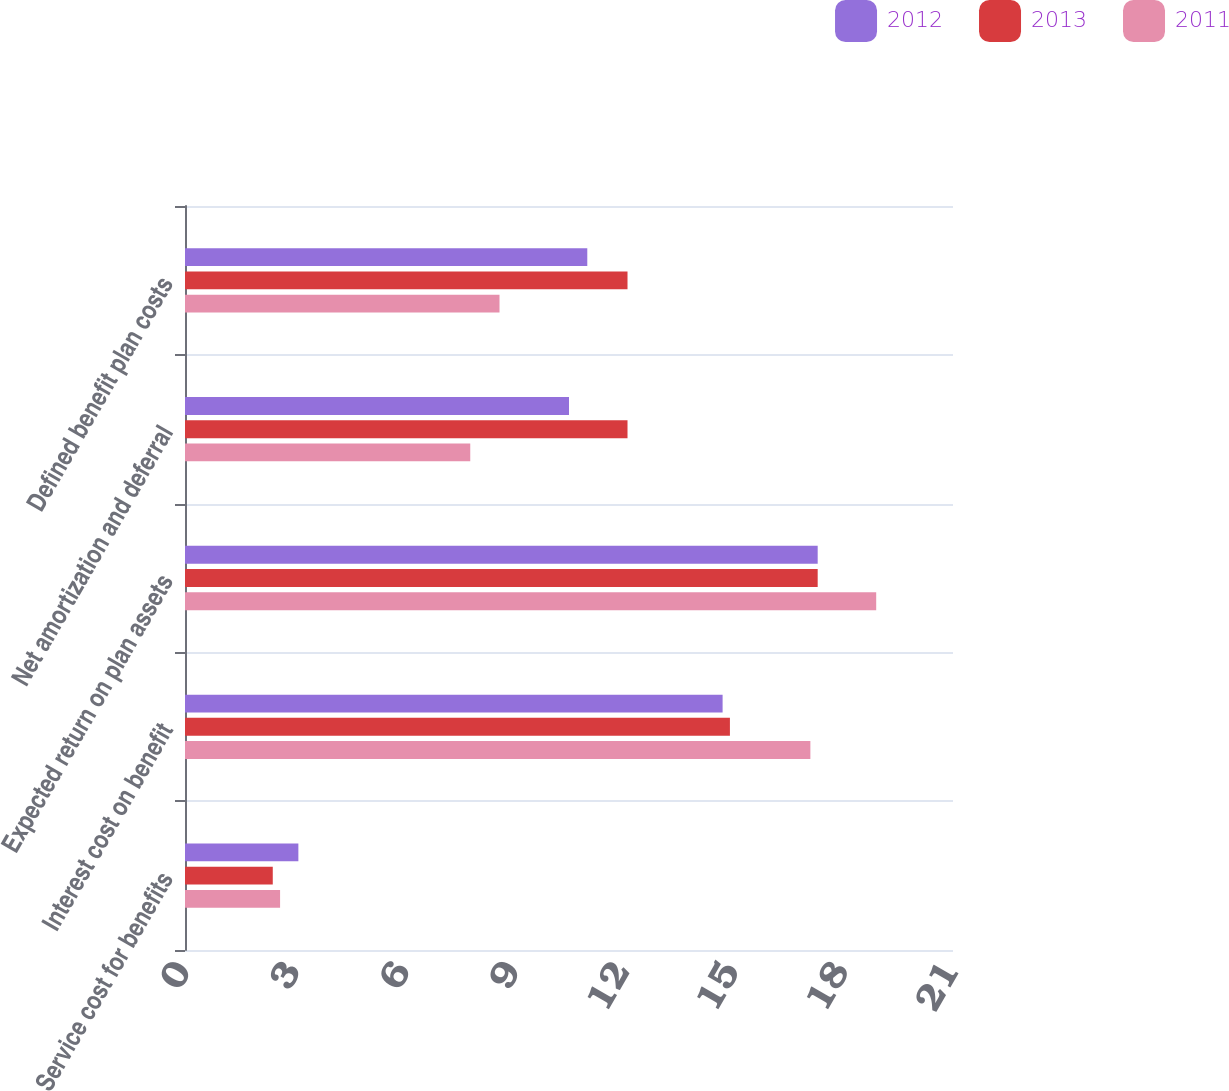Convert chart to OTSL. <chart><loc_0><loc_0><loc_500><loc_500><stacked_bar_chart><ecel><fcel>Service cost for benefits<fcel>Interest cost on benefit<fcel>Expected return on plan assets<fcel>Net amortization and deferral<fcel>Defined benefit plan costs<nl><fcel>2012<fcel>3.1<fcel>14.7<fcel>17.3<fcel>10.5<fcel>11<nl><fcel>2013<fcel>2.4<fcel>14.9<fcel>17.3<fcel>12.1<fcel>12.1<nl><fcel>2011<fcel>2.6<fcel>17.1<fcel>18.9<fcel>7.8<fcel>8.6<nl></chart> 